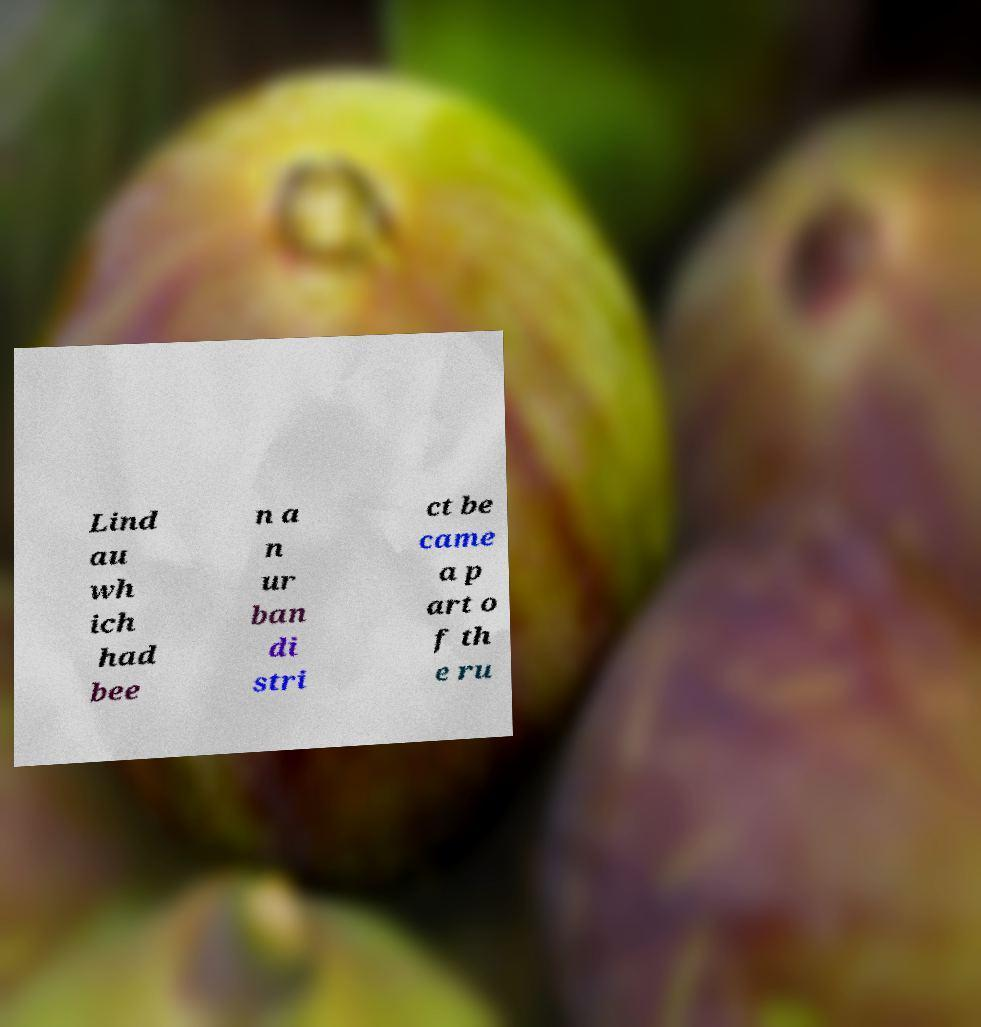Could you assist in decoding the text presented in this image and type it out clearly? Lind au wh ich had bee n a n ur ban di stri ct be came a p art o f th e ru 